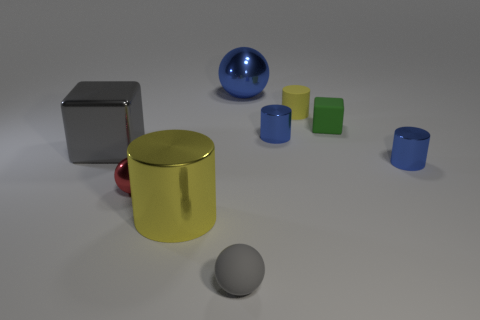What might be the context or purpose of this arrangement of objects? This image suggests a controlled setting, possibly for a study of materials and light interaction or a 3D modeling test scene. The objects appear carefully placed without overlap, perhaps to observe reflections, shadows, and color contrasts in a neutral environment, likely a digital simulation or a product display setting. 